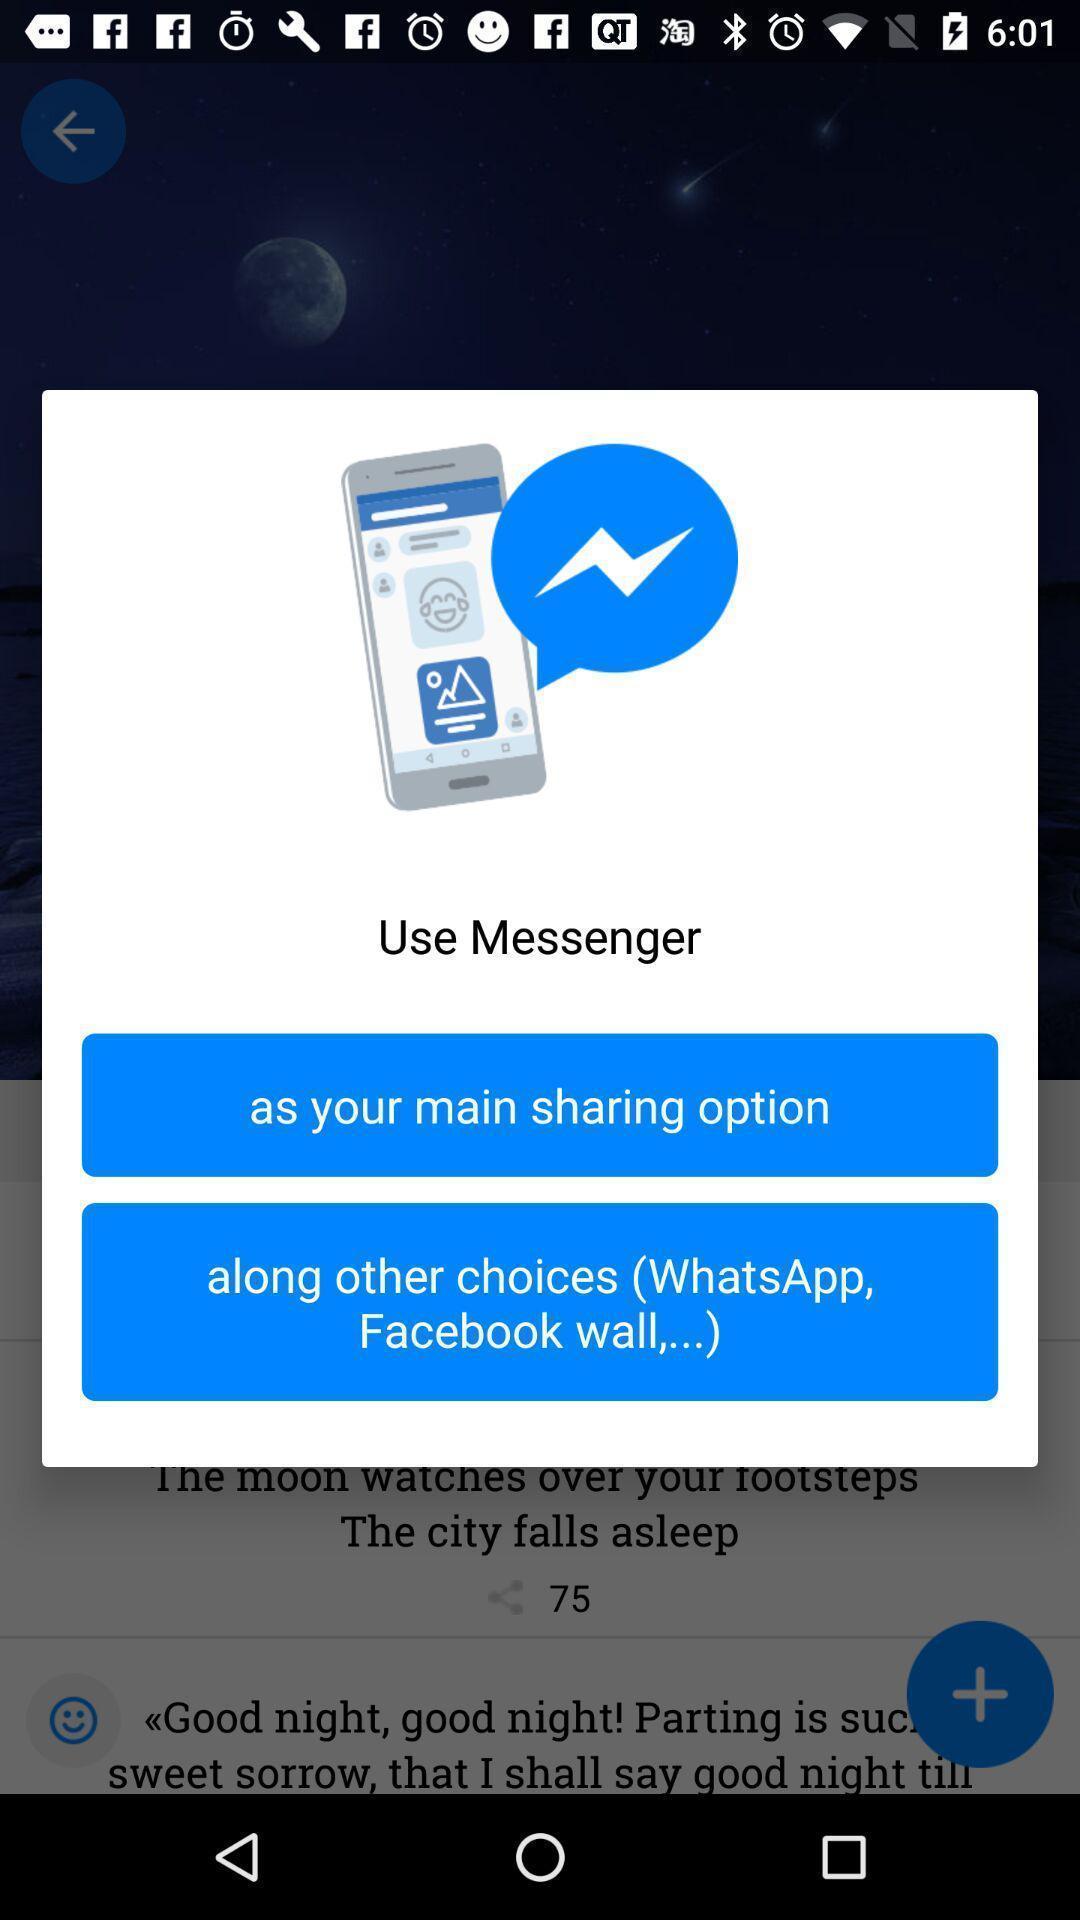Summarize the information in this screenshot. Signup page s. 